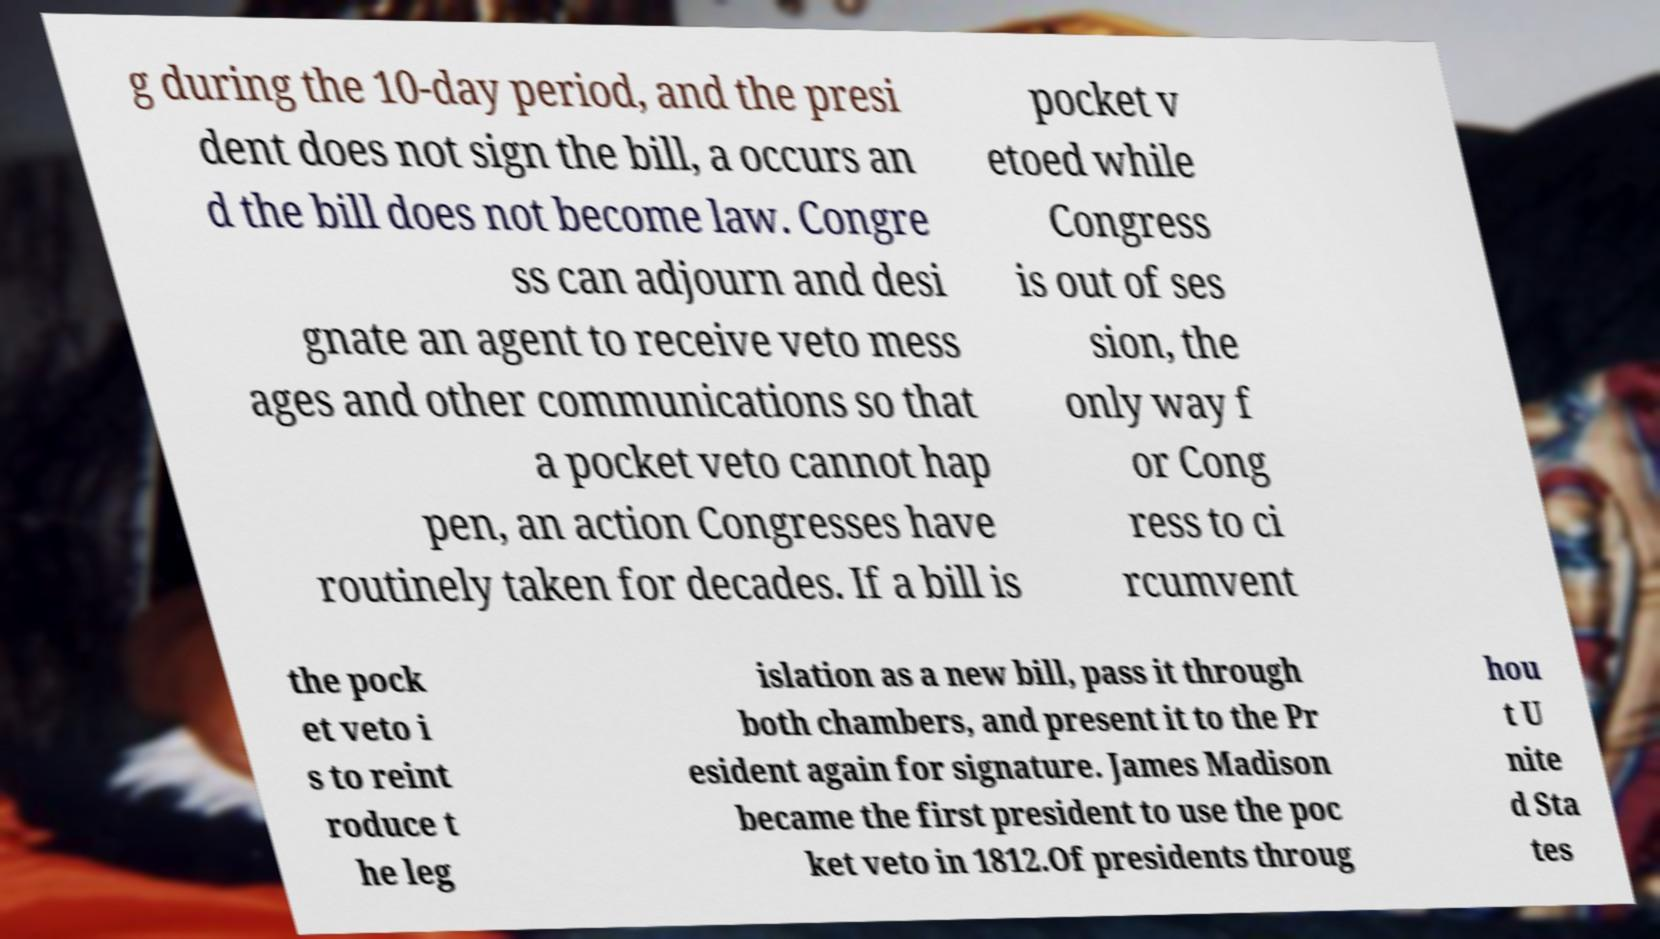Can you read and provide the text displayed in the image?This photo seems to have some interesting text. Can you extract and type it out for me? g during the 10-day period, and the presi dent does not sign the bill, a occurs an d the bill does not become law. Congre ss can adjourn and desi gnate an agent to receive veto mess ages and other communications so that a pocket veto cannot hap pen, an action Congresses have routinely taken for decades. If a bill is pocket v etoed while Congress is out of ses sion, the only way f or Cong ress to ci rcumvent the pock et veto i s to reint roduce t he leg islation as a new bill, pass it through both chambers, and present it to the Pr esident again for signature. James Madison became the first president to use the poc ket veto in 1812.Of presidents throug hou t U nite d Sta tes 